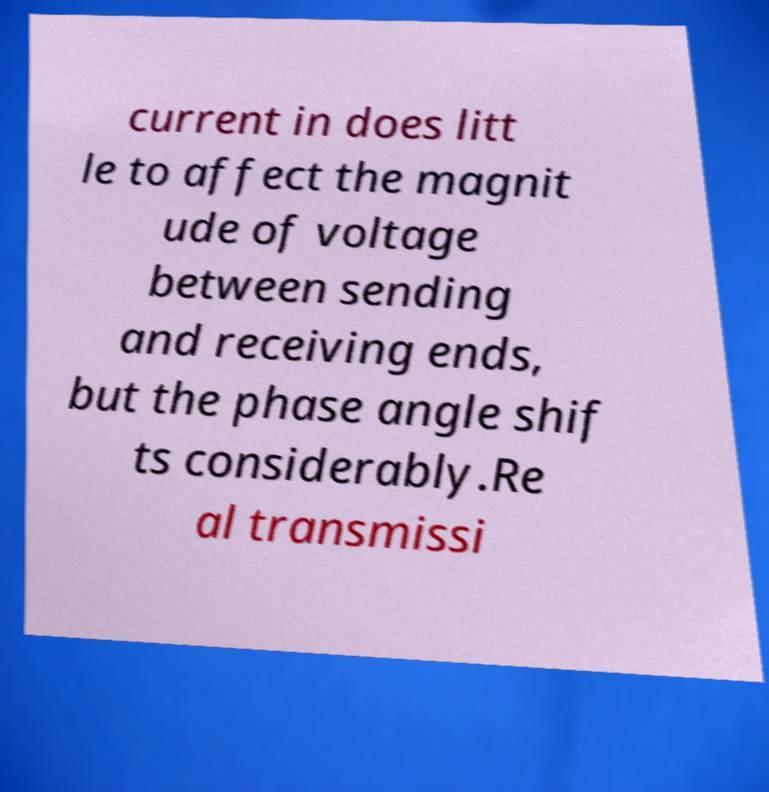Can you read and provide the text displayed in the image?This photo seems to have some interesting text. Can you extract and type it out for me? current in does litt le to affect the magnit ude of voltage between sending and receiving ends, but the phase angle shif ts considerably.Re al transmissi 